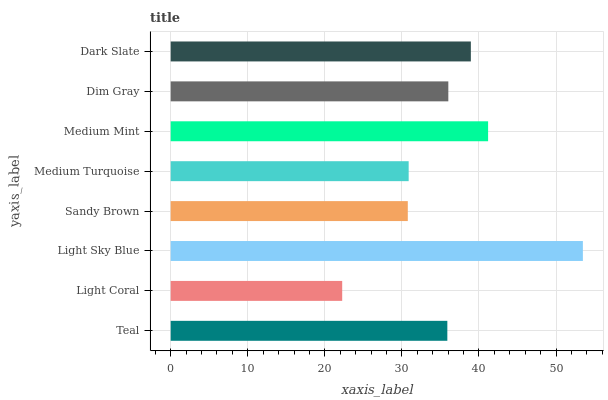Is Light Coral the minimum?
Answer yes or no. Yes. Is Light Sky Blue the maximum?
Answer yes or no. Yes. Is Light Sky Blue the minimum?
Answer yes or no. No. Is Light Coral the maximum?
Answer yes or no. No. Is Light Sky Blue greater than Light Coral?
Answer yes or no. Yes. Is Light Coral less than Light Sky Blue?
Answer yes or no. Yes. Is Light Coral greater than Light Sky Blue?
Answer yes or no. No. Is Light Sky Blue less than Light Coral?
Answer yes or no. No. Is Dim Gray the high median?
Answer yes or no. Yes. Is Teal the low median?
Answer yes or no. Yes. Is Light Sky Blue the high median?
Answer yes or no. No. Is Light Coral the low median?
Answer yes or no. No. 